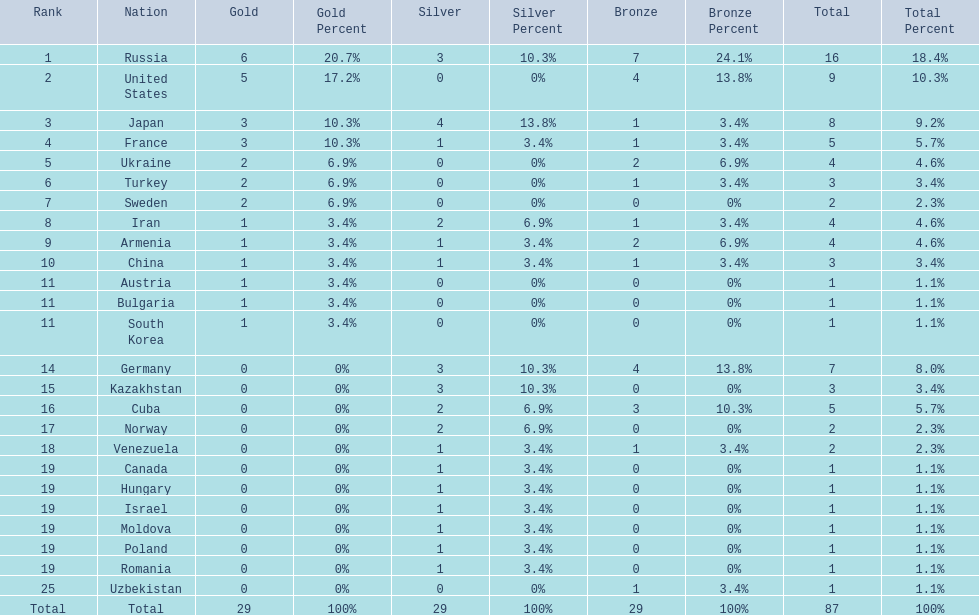Could you help me parse every detail presented in this table? {'header': ['Rank', 'Nation', 'Gold', 'Gold Percent', 'Silver', 'Silver Percent', 'Bronze', 'Bronze Percent', 'Total', 'Total Percent'], 'rows': [['1', 'Russia', '6', '20.7%', '3', '10.3%', '7', '24.1%', '16', '18.4%'], ['2', 'United States', '5', '17.2%', '0', '0%', '4', '13.8%', '9', '10.3%'], ['3', 'Japan', '3', '10.3%', '4', '13.8%', '1', '3.4%', '8', '9.2%'], ['4', 'France', '3', '10.3%', '1', '3.4%', '1', '3.4%', '5', '5.7%'], ['5', 'Ukraine', '2', '6.9%', '0', '0%', '2', '6.9%', '4', '4.6%'], ['6', 'Turkey', '2', '6.9%', '0', '0%', '1', '3.4%', '3', '3.4%'], ['7', 'Sweden', '2', '6.9%', '0', '0%', '0', '0%', '2', '2.3%'], ['8', 'Iran', '1', '3.4%', '2', '6.9%', '1', '3.4%', '4', '4.6%'], ['9', 'Armenia', '1', '3.4%', '1', '3.4%', '2', '6.9%', '4', '4.6%'], ['10', 'China', '1', '3.4%', '1', '3.4%', '1', '3.4%', '3', '3.4%'], ['11', 'Austria', '1', '3.4%', '0', '0%', '0', '0%', '1', '1.1%'], ['11', 'Bulgaria', '1', '3.4%', '0', '0%', '0', '0%', '1', '1.1%'], ['11', 'South Korea', '1', '3.4%', '0', '0%', '0', '0%', '1', '1.1%'], ['14', 'Germany', '0', '0%', '3', '10.3%', '4', '13.8%', '7', '8.0%'], ['15', 'Kazakhstan', '0', '0%', '3', '10.3%', '0', '0%', '3', '3.4%'], ['16', 'Cuba', '0', '0%', '2', '6.9%', '3', '10.3%', '5', '5.7%'], ['17', 'Norway', '0', '0%', '2', '6.9%', '0', '0%', '2', '2.3%'], ['18', 'Venezuela', '0', '0%', '1', '3.4%', '1', '3.4%', '2', '2.3%'], ['19', 'Canada', '0', '0%', '1', '3.4%', '0', '0%', '1', '1.1%'], ['19', 'Hungary', '0', '0%', '1', '3.4%', '0', '0%', '1', '1.1%'], ['19', 'Israel', '0', '0%', '1', '3.4%', '0', '0%', '1', '1.1%'], ['19', 'Moldova', '0', '0%', '1', '3.4%', '0', '0%', '1', '1.1%'], ['19', 'Poland', '0', '0%', '1', '3.4%', '0', '0%', '1', '1.1%'], ['19', 'Romania', '0', '0%', '1', '3.4%', '0', '0%', '1', '1.1%'], ['25', 'Uzbekistan', '0', '0%', '0', '0%', '1', '3.4%', '1', '1.1%'], ['Total', 'Total', '29', '100%', '29', '100%', '29', '100%', '87', '100%']]} Which nations have gold medals? Russia, United States, Japan, France, Ukraine, Turkey, Sweden, Iran, Armenia, China, Austria, Bulgaria, South Korea. Of those nations, which have only one gold medal? Iran, Armenia, China, Austria, Bulgaria, South Korea. Of those nations, which has no bronze or silver medals? Austria. 